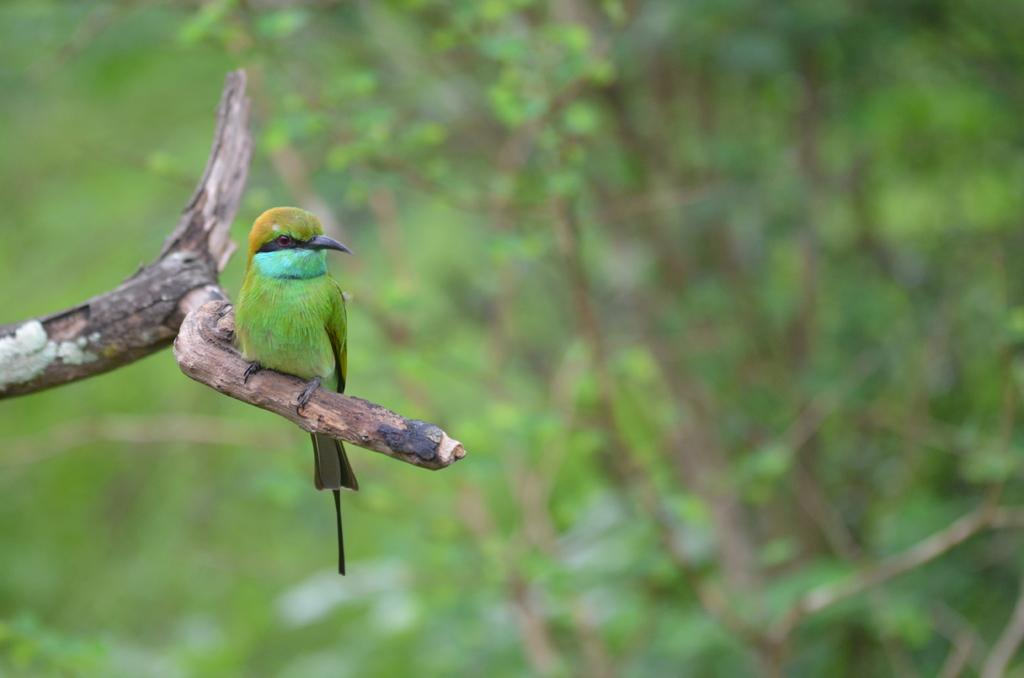What type of animal can be seen in the image? There is a bird in the image. Where is the bird located? The bird is on a branch. What can be observed about the background of the image? The background of the image is blurred. What type of vegetation is present in the background? There is greenery in the background of the image. How many eggs can be seen in the image? There are no eggs present in the image. What type of tree is the bird perched on in the image? The provided facts do not mention the type of tree, only that the bird is on a branch. 